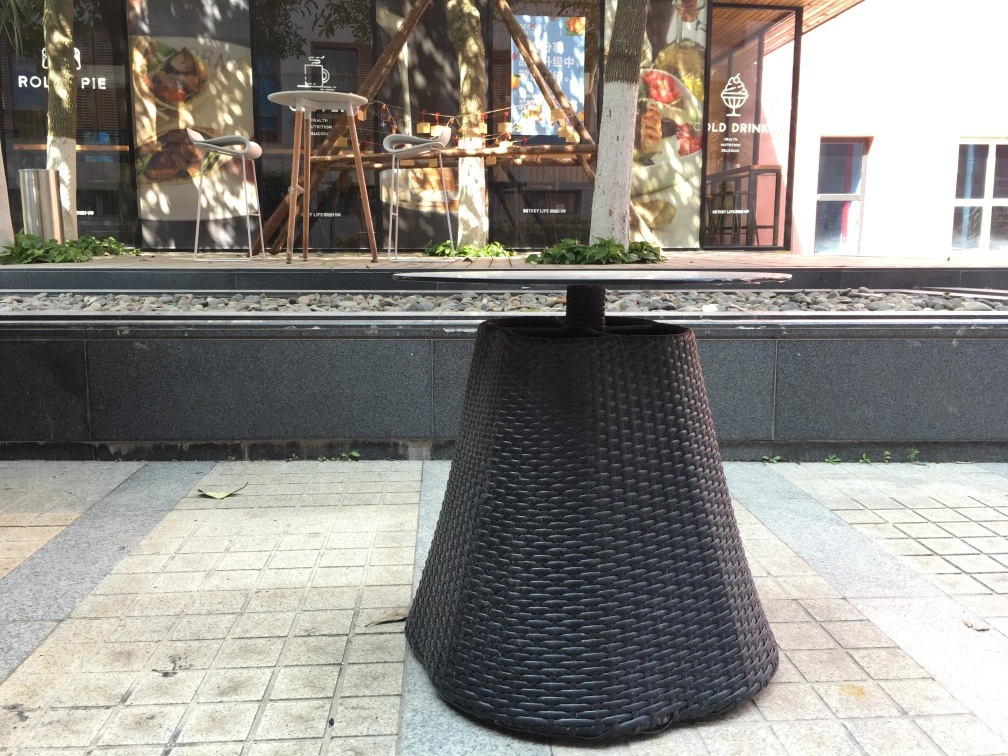Is this a functioning café or a display? It appears to be a functioning café, as indicated by the signboard advertising cold drinks inside the shop. The café might be closed temporarily or simply not have any patrons at the moment the picture was taken. What details suggest the time of day this photo was taken? The shadows on the ground suggest that this photo was taken at a time when the sun was moderately high, likely late morning or early afternoon. The bright sunlight and absence of artificial lighting also support this deduction. 